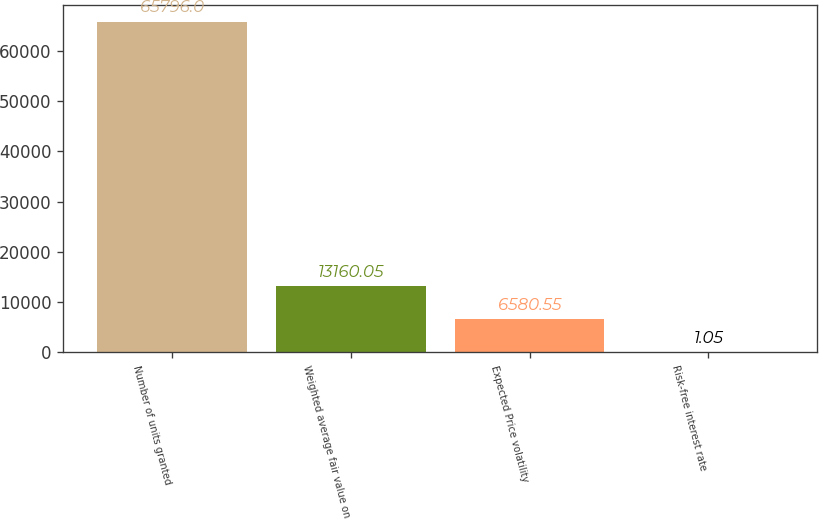Convert chart to OTSL. <chart><loc_0><loc_0><loc_500><loc_500><bar_chart><fcel>Number of units granted<fcel>Weighted average fair value on<fcel>Expected Price volatility<fcel>Risk-free interest rate<nl><fcel>65796<fcel>13160<fcel>6580.55<fcel>1.05<nl></chart> 